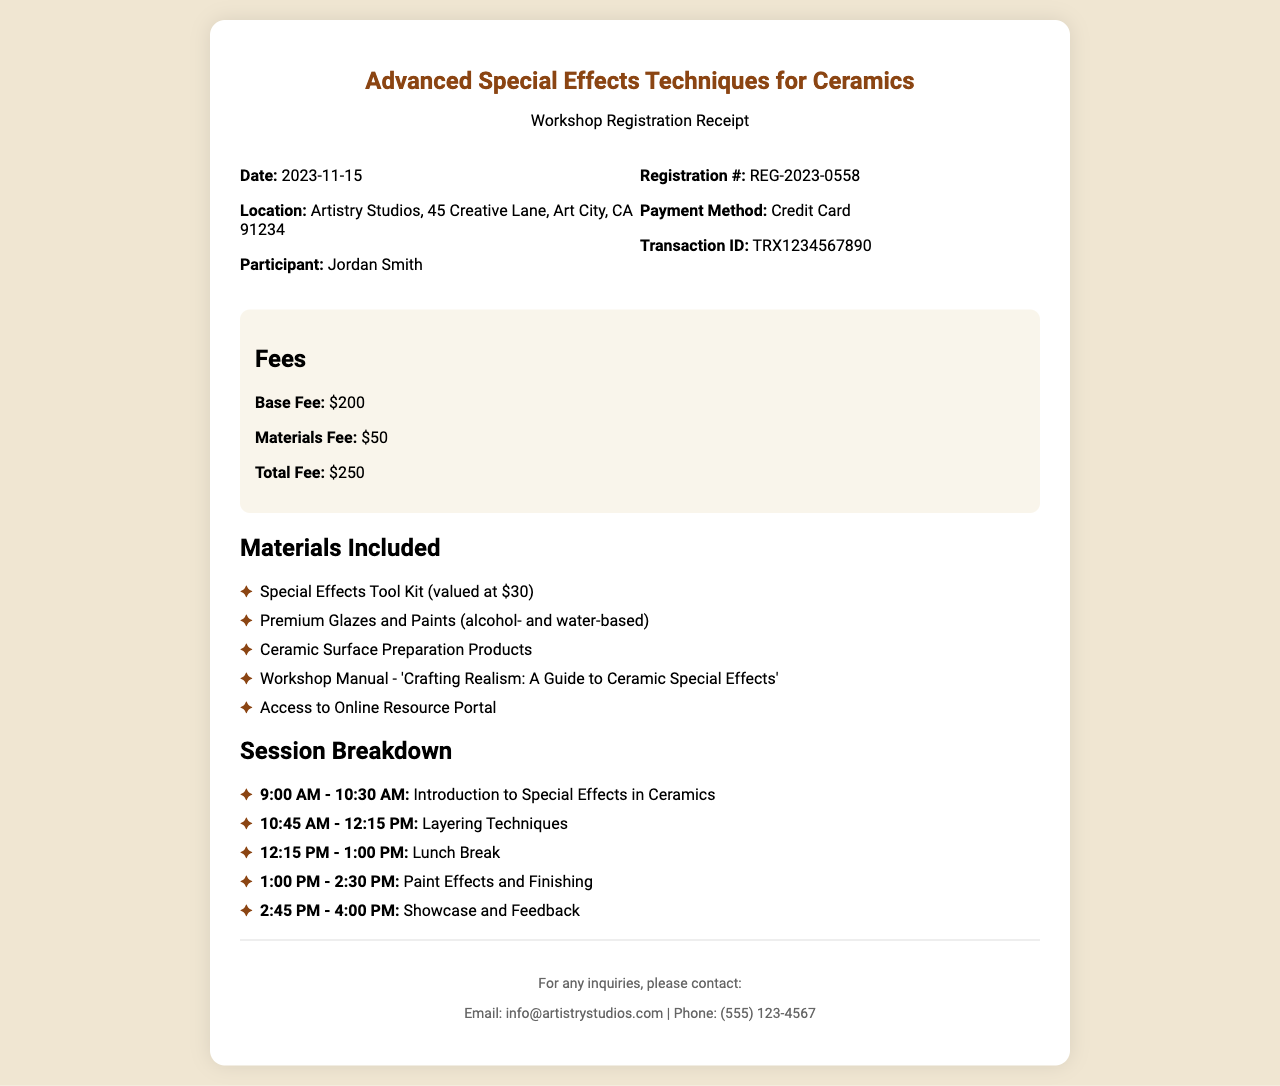What is the workshop date? The workshop date is specified in the document as the date of the event, which is November 15, 2023.
Answer: November 15, 2023 What is the total fee for the workshop? The total fee is the sum of the base fee and materials fee, which is listed as $250 in the document.
Answer: $250 Who is the participant registered for the workshop? The participant's name is shown in the registration details of the receipt.
Answer: Jordan Smith What is included in the special effects tool kit? The document specifies the special effects tool kit is valued at $30, highlighting it as part of the materials included.
Answer: Special Effects Tool Kit What session covers layering techniques? The time of the session focused on layering techniques is provided in the schedule section of the document.
Answer: 10:45 AM - 12:15 PM What is the location of the workshop? The location of the workshop is mentioned in the document as Artistry Studios on Creative Lane.
Answer: Artistry Studios, 45 Creative Lane, Art City, CA 91234 What payment method was used for registration? The document includes details about the payment method used for the workshop registration.
Answer: Credit Card What is the title of the workshop manual included? The title of the workshop manual included in the materials is specified in the document.
Answer: Crafting Realism: A Guide to Ceramic Special Effects What is the contact email for inquiries? The contact email for any inquiries related to the workshop is provided in the footer of the receipt.
Answer: info@artistrystudios.com 